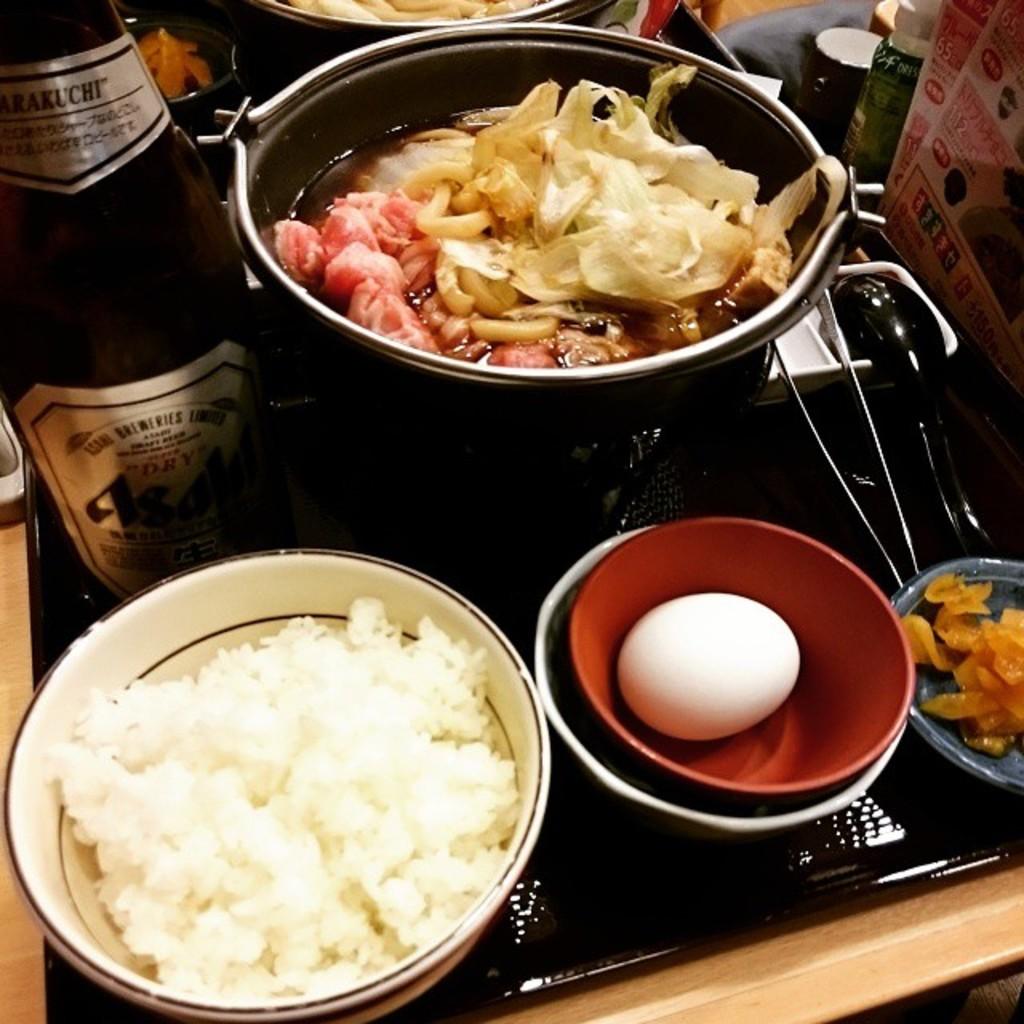What number is not covered in the menu on our table/?
Make the answer very short. Unanswerable. The drink is not wet but...?
Make the answer very short. Dry. 